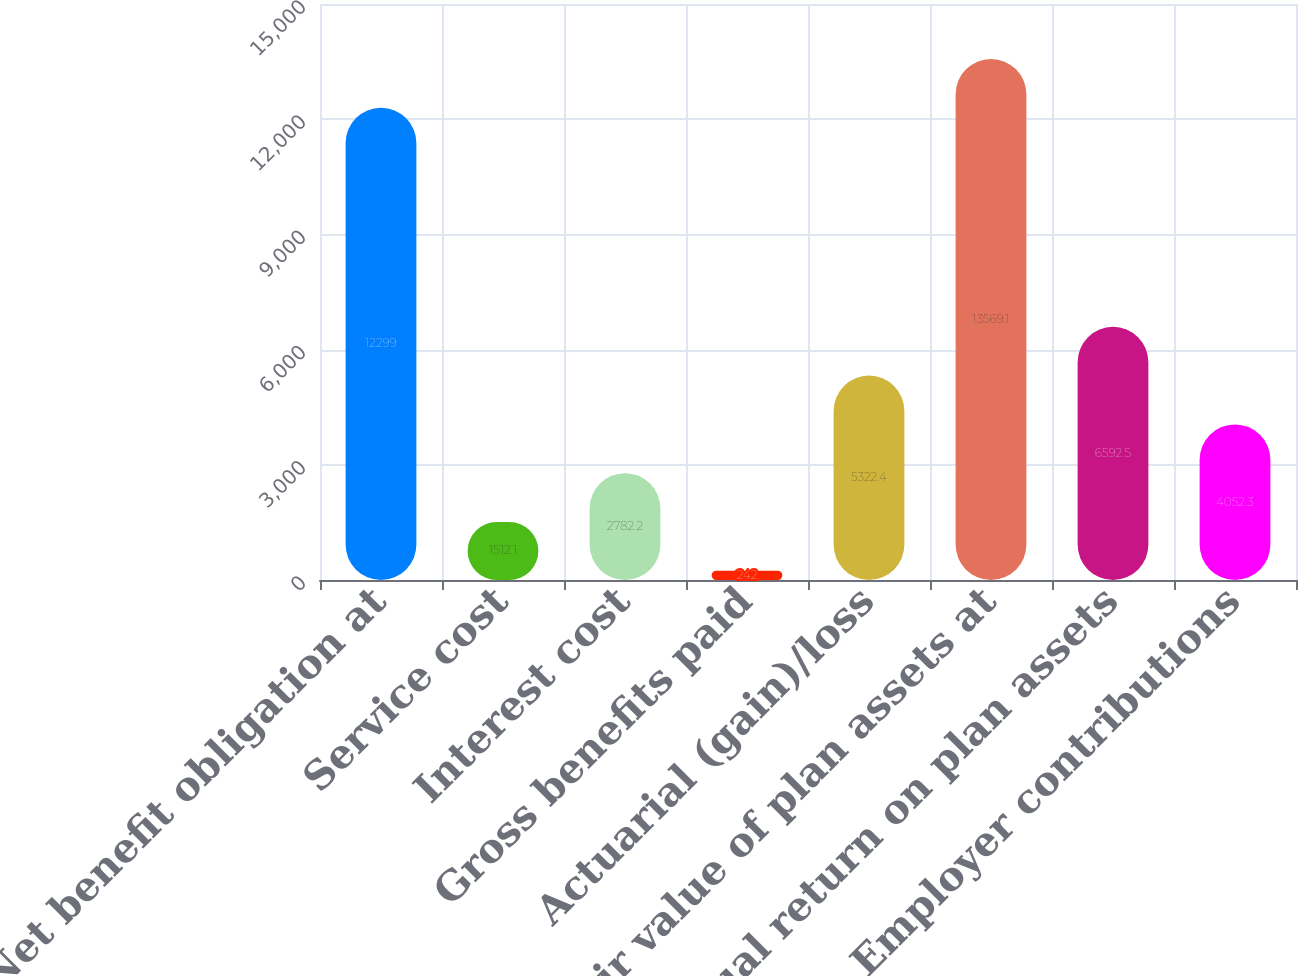Convert chart. <chart><loc_0><loc_0><loc_500><loc_500><bar_chart><fcel>Net benefit obligation at<fcel>Service cost<fcel>Interest cost<fcel>Gross benefits paid<fcel>Actuarial (gain)/loss<fcel>Fair value of plan assets at<fcel>Actual return on plan assets<fcel>Employer contributions<nl><fcel>12299<fcel>1512.1<fcel>2782.2<fcel>242<fcel>5322.4<fcel>13569.1<fcel>6592.5<fcel>4052.3<nl></chart> 